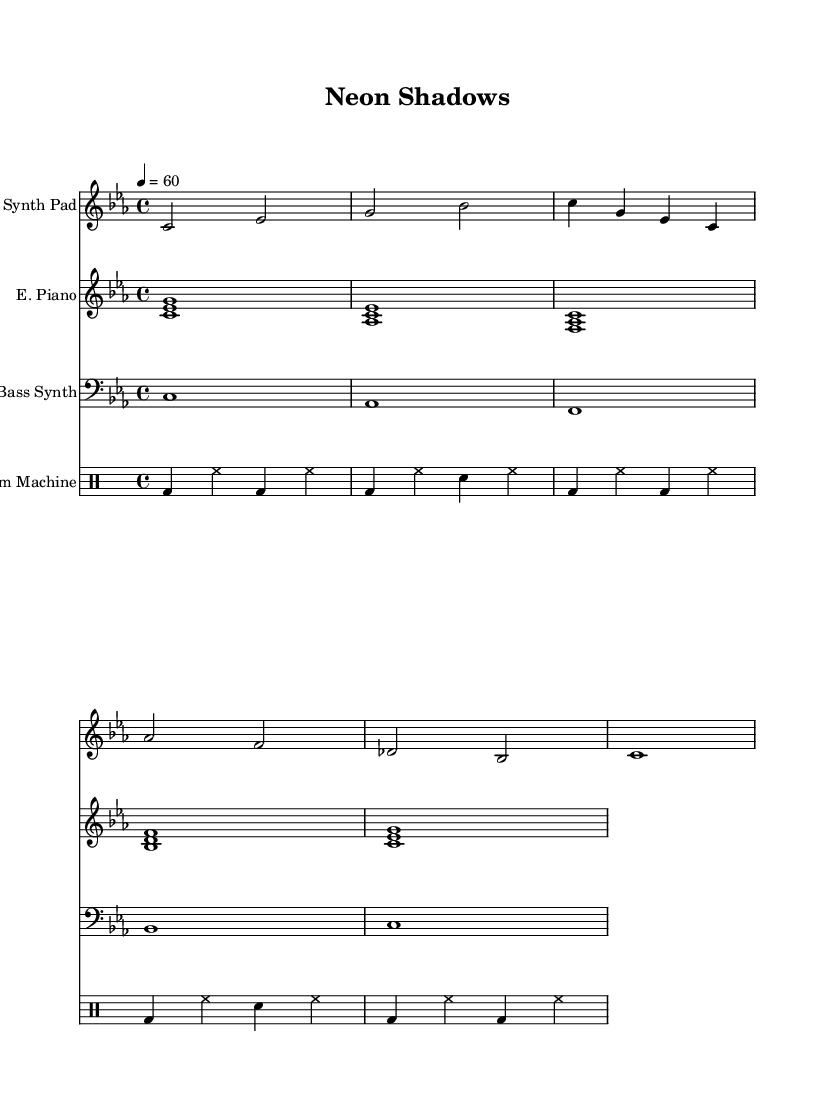What is the key signature of this music? The key signature shown in the music indicates that there are three flats, which corresponds to C minor.
Answer: C minor What is the time signature of this piece? The time signature displayed in the music is a common time, represented by the 4 over 4, meaning there are four beats per measure.
Answer: 4/4 What is the tempo marking of the piece? The tempo marking indicates a tempo of 60 beats per minute, denoting a slow and relaxed pace.
Answer: 60 How many measures does the drum machine part have? Counting the repeated sections in the drum machine part reveals it has a total of four measures, repeated twice.
Answer: 4 What instruments are included in the score? The score includes a Synth Pad, Electric Piano, Bass Synth, and Drum Machine, each labeled clearly on the staff.
Answer: Synth Pad, Electric Piano, Bass Synth, Drum Machine How are the synth pad and bass synth notes structured in terms of length? Both the Synth Pad and Bass Synth incorporate longer note values, with the Synth Pad using half notes and the Bass Synth using whole notes, which contributes to the ambient feel.
Answer: Half notes, Whole notes What type of harmony does the electric piano part use? The electric piano part uses stacked chords, specifically major and minor triads, which create a lush harmonic texture suitable for ambient music.
Answer: Chords 